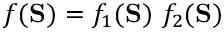<formula> <loc_0><loc_0><loc_500><loc_500>f ( S ) = f _ { 1 } ( S ) f _ { 2 } ( S )</formula> 